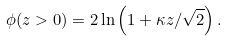Convert formula to latex. <formula><loc_0><loc_0><loc_500><loc_500>\phi ( z > 0 ) = 2 \ln \left ( 1 + \kappa z / \sqrt { 2 } \right ) .</formula> 